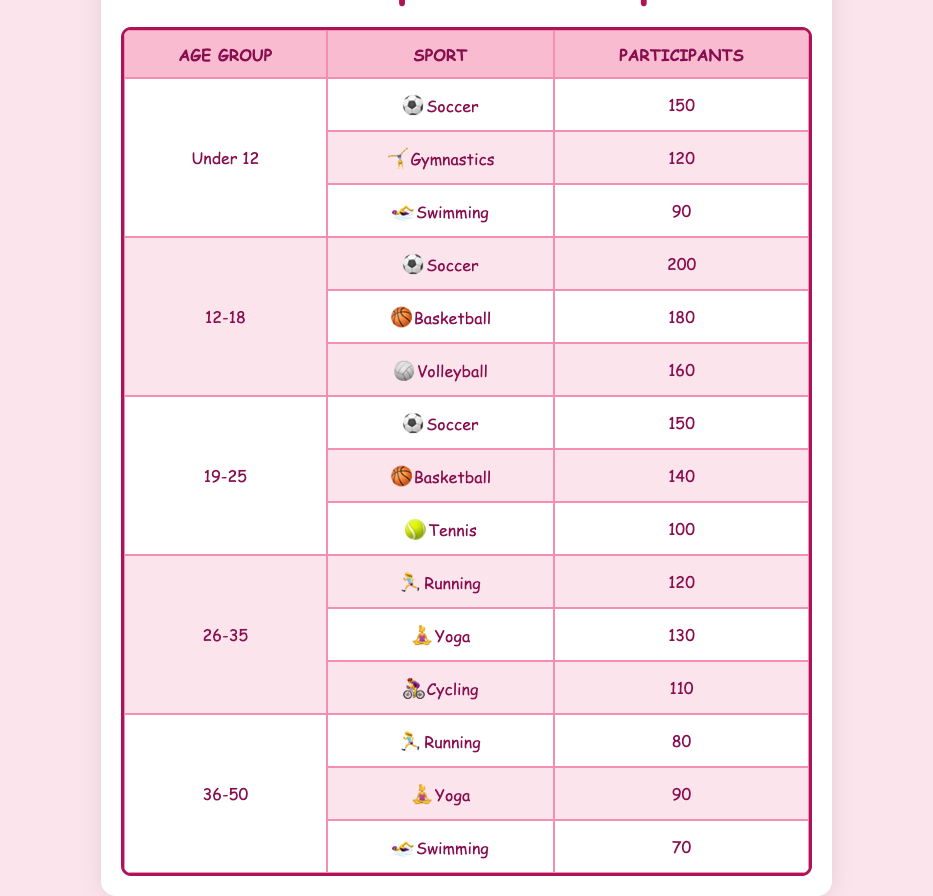What sport had the highest participation among women aged 12-18? In the age group of 12-18, the sports listed are Soccer (200 participants), Basketball (180 participants), and Volleyball (160 participants). Comparing these numbers, Soccer has the highest participation with 200.
Answer: Soccer How many participants were there in total for the sport of Yoga across all age groups? The sport Yoga appears in the age groups 26-35 (130 participants) and 36-50 (90 participants). Adding these together gives 130 + 90 = 220 participants in total for Yoga.
Answer: 220 Is there more participation in Basketball or Volleyball among women aged 12-18? For the age group 12-18, Basketball has 180 participants and Volleyball has 160 participants. Since 180 is greater than 160, there is more participation in Basketball.
Answer: Yes What is the average number of participants in sports for women aged 19-25? The sports for the age group 19-25 are Soccer (150 participants), Basketball (140 participants), and Tennis (100 participants). To find the average, we add these: 150 + 140 + 100 = 390, and then divide by the number of sports (3): 390 / 3 = 130.
Answer: 130 What sport had the least participation among women aged 36-50? In this age group, the sports listed are Running (80 participants), Yoga (90 participants), and Swimming (70 participants). Comparing these, Swimming with 70 participants has the least participation.
Answer: Swimming How many more participants were there in Soccer compared to Gymnastics for women under 12? For women under 12, Soccer has 150 participants and Gymnastics has 120 participants. The difference is 150 - 120 = 30 participants more in Soccer compared to Gymnastics.
Answer: 30 What is the total participants for the ages 26-35 across all sports? The sports for the age group 26-35 include Running (120 participants), Yoga (130 participants), and Cycling (110 participants). The total is calculated by adding: 120 + 130 + 110 = 360 participants total for this age group.
Answer: 360 Is there a sport that has equal or more than 200 participants in any age group? Looking through the ages, only the age group 12-18 has Soccer with 200 participants. All other sports and age groups have fewer than 200 participants. Therefore, Soccer is the only sport with equal or more than 200 in the table.
Answer: Yes 